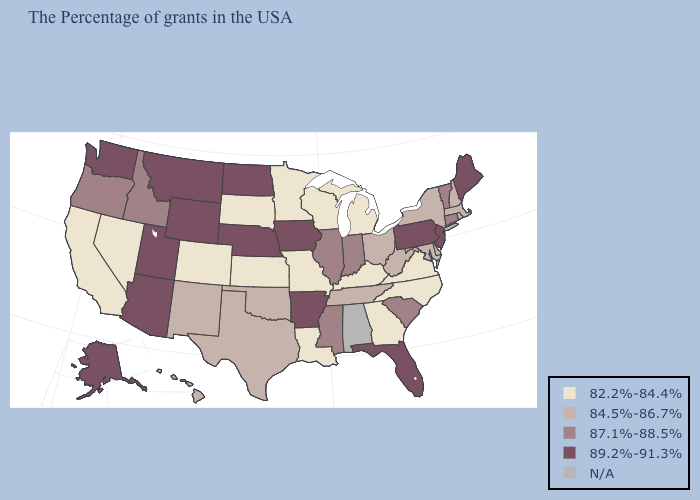Name the states that have a value in the range N/A?
Quick response, please. Alabama. Which states have the highest value in the USA?
Answer briefly. Maine, New Jersey, Pennsylvania, Florida, Arkansas, Iowa, Nebraska, North Dakota, Wyoming, Utah, Montana, Arizona, Washington, Alaska. What is the highest value in states that border New York?
Short answer required. 89.2%-91.3%. What is the value of Indiana?
Answer briefly. 87.1%-88.5%. What is the highest value in states that border Virginia?
Keep it brief. 84.5%-86.7%. Is the legend a continuous bar?
Concise answer only. No. Name the states that have a value in the range 84.5%-86.7%?
Short answer required. Massachusetts, Rhode Island, New Hampshire, New York, Delaware, Maryland, West Virginia, Ohio, Tennessee, Oklahoma, Texas, New Mexico, Hawaii. What is the highest value in the MidWest ?
Answer briefly. 89.2%-91.3%. Among the states that border Minnesota , does Iowa have the lowest value?
Keep it brief. No. Name the states that have a value in the range 87.1%-88.5%?
Give a very brief answer. Vermont, Connecticut, South Carolina, Indiana, Illinois, Mississippi, Idaho, Oregon. What is the value of North Carolina?
Give a very brief answer. 82.2%-84.4%. What is the value of Massachusetts?
Be succinct. 84.5%-86.7%. What is the highest value in states that border Texas?
Answer briefly. 89.2%-91.3%. 